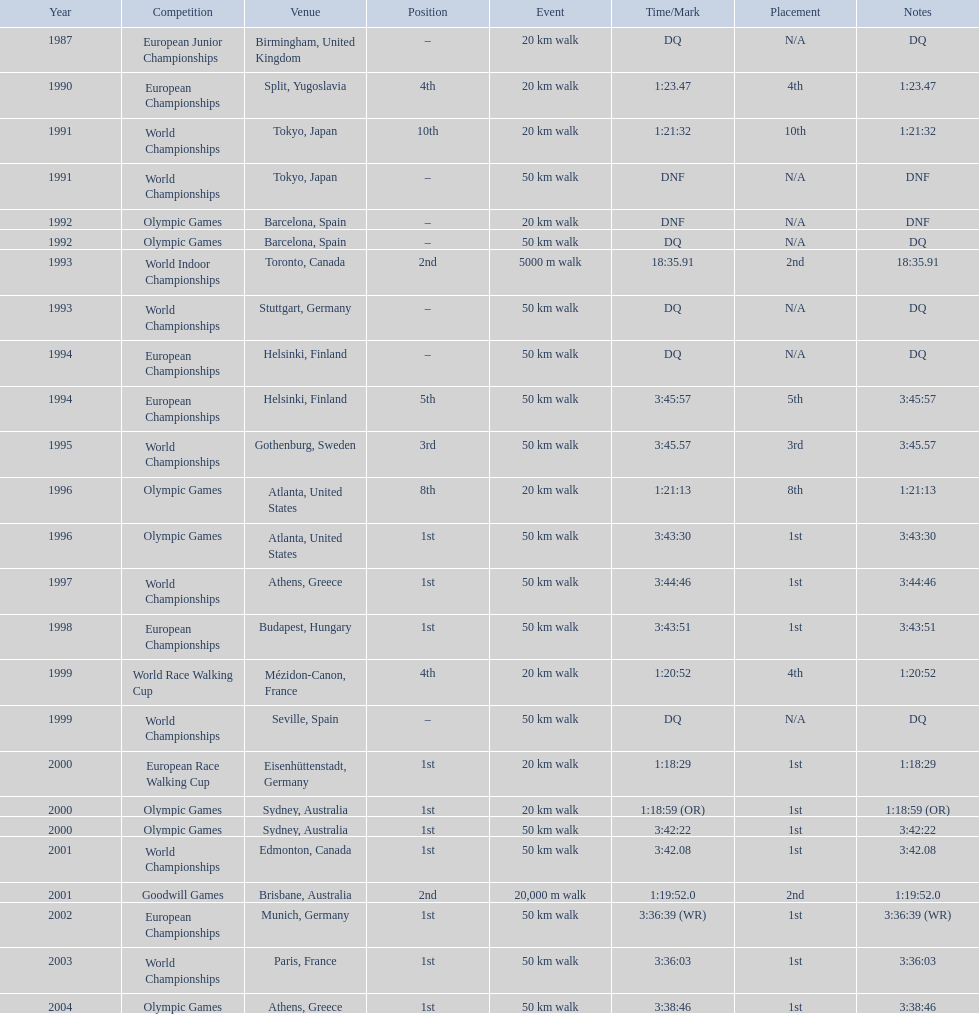How many times was first place listed as the position? 10. 